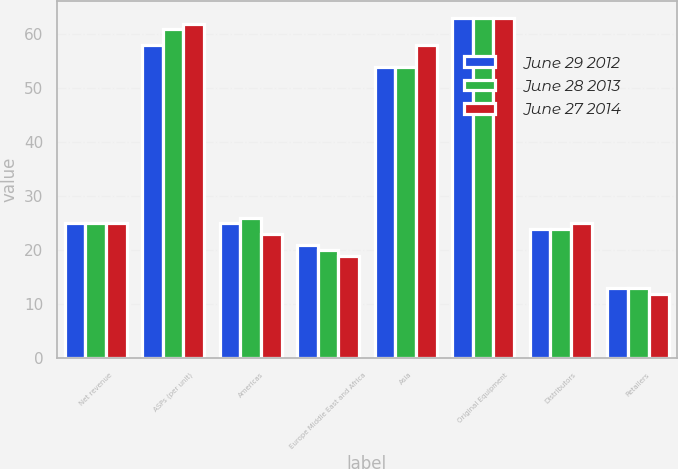Convert chart. <chart><loc_0><loc_0><loc_500><loc_500><stacked_bar_chart><ecel><fcel>Net revenue<fcel>ASPs (per unit)<fcel>Americas<fcel>Europe Middle East and Africa<fcel>Asia<fcel>Original Equipment<fcel>Distributors<fcel>Retailers<nl><fcel>June 29 2012<fcel>25<fcel>58<fcel>25<fcel>21<fcel>54<fcel>63<fcel>24<fcel>13<nl><fcel>June 28 2013<fcel>25<fcel>61<fcel>26<fcel>20<fcel>54<fcel>63<fcel>24<fcel>13<nl><fcel>June 27 2014<fcel>25<fcel>62<fcel>23<fcel>19<fcel>58<fcel>63<fcel>25<fcel>12<nl></chart> 